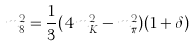Convert formula to latex. <formula><loc_0><loc_0><loc_500><loc_500>m ^ { 2 } _ { 8 } = \frac { 1 } { 3 } ( 4 m ^ { 2 } _ { K } - m ^ { 2 } _ { \pi } ) ( 1 + \delta )</formula> 